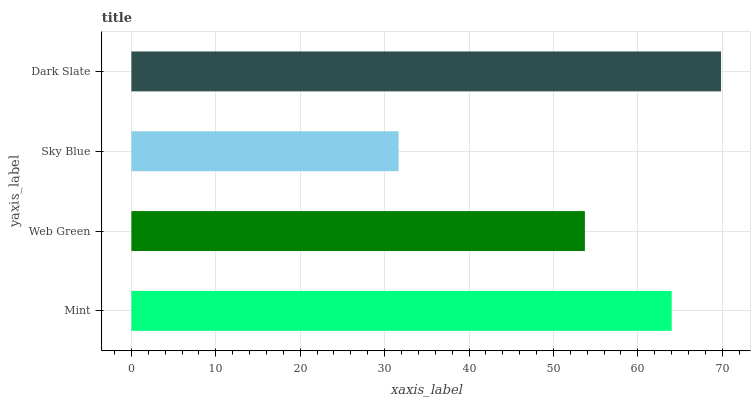Is Sky Blue the minimum?
Answer yes or no. Yes. Is Dark Slate the maximum?
Answer yes or no. Yes. Is Web Green the minimum?
Answer yes or no. No. Is Web Green the maximum?
Answer yes or no. No. Is Mint greater than Web Green?
Answer yes or no. Yes. Is Web Green less than Mint?
Answer yes or no. Yes. Is Web Green greater than Mint?
Answer yes or no. No. Is Mint less than Web Green?
Answer yes or no. No. Is Mint the high median?
Answer yes or no. Yes. Is Web Green the low median?
Answer yes or no. Yes. Is Web Green the high median?
Answer yes or no. No. Is Sky Blue the low median?
Answer yes or no. No. 